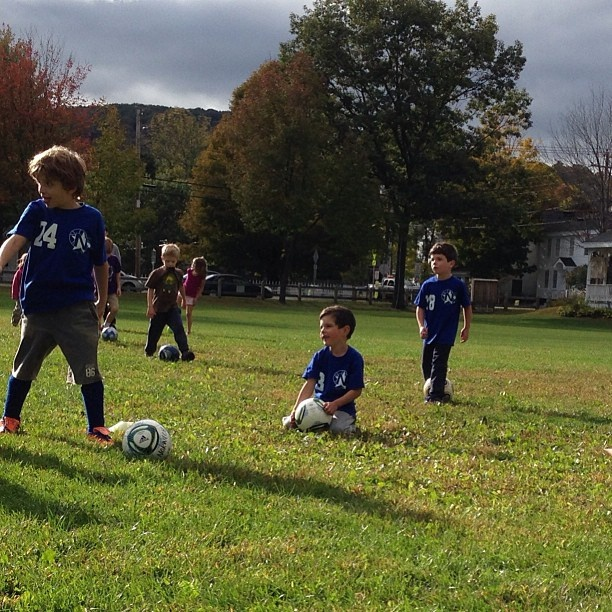Describe the objects in this image and their specific colors. I can see people in darkgray, black, maroon, and gray tones, people in darkgray, black, maroon, and gray tones, people in darkgray, black, maroon, and gray tones, people in darkgray, black, maroon, and gray tones, and sports ball in darkgray, black, and gray tones in this image. 